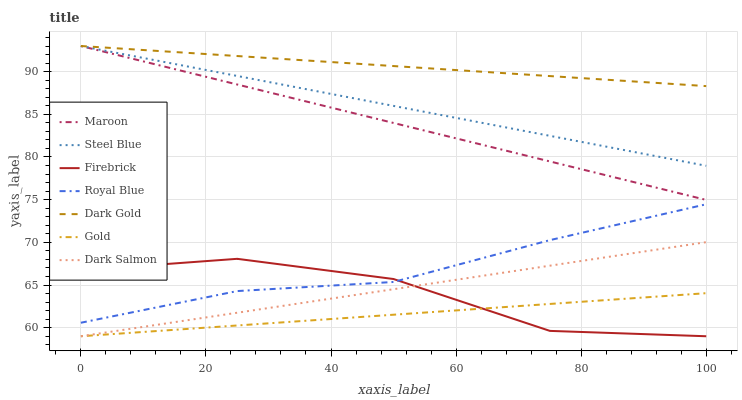Does Gold have the minimum area under the curve?
Answer yes or no. Yes. Does Dark Gold have the maximum area under the curve?
Answer yes or no. Yes. Does Firebrick have the minimum area under the curve?
Answer yes or no. No. Does Firebrick have the maximum area under the curve?
Answer yes or no. No. Is Gold the smoothest?
Answer yes or no. Yes. Is Firebrick the roughest?
Answer yes or no. Yes. Is Dark Gold the smoothest?
Answer yes or no. No. Is Dark Gold the roughest?
Answer yes or no. No. Does Gold have the lowest value?
Answer yes or no. Yes. Does Dark Gold have the lowest value?
Answer yes or no. No. Does Maroon have the highest value?
Answer yes or no. Yes. Does Firebrick have the highest value?
Answer yes or no. No. Is Gold less than Maroon?
Answer yes or no. Yes. Is Royal Blue greater than Gold?
Answer yes or no. Yes. Does Steel Blue intersect Dark Gold?
Answer yes or no. Yes. Is Steel Blue less than Dark Gold?
Answer yes or no. No. Is Steel Blue greater than Dark Gold?
Answer yes or no. No. Does Gold intersect Maroon?
Answer yes or no. No. 